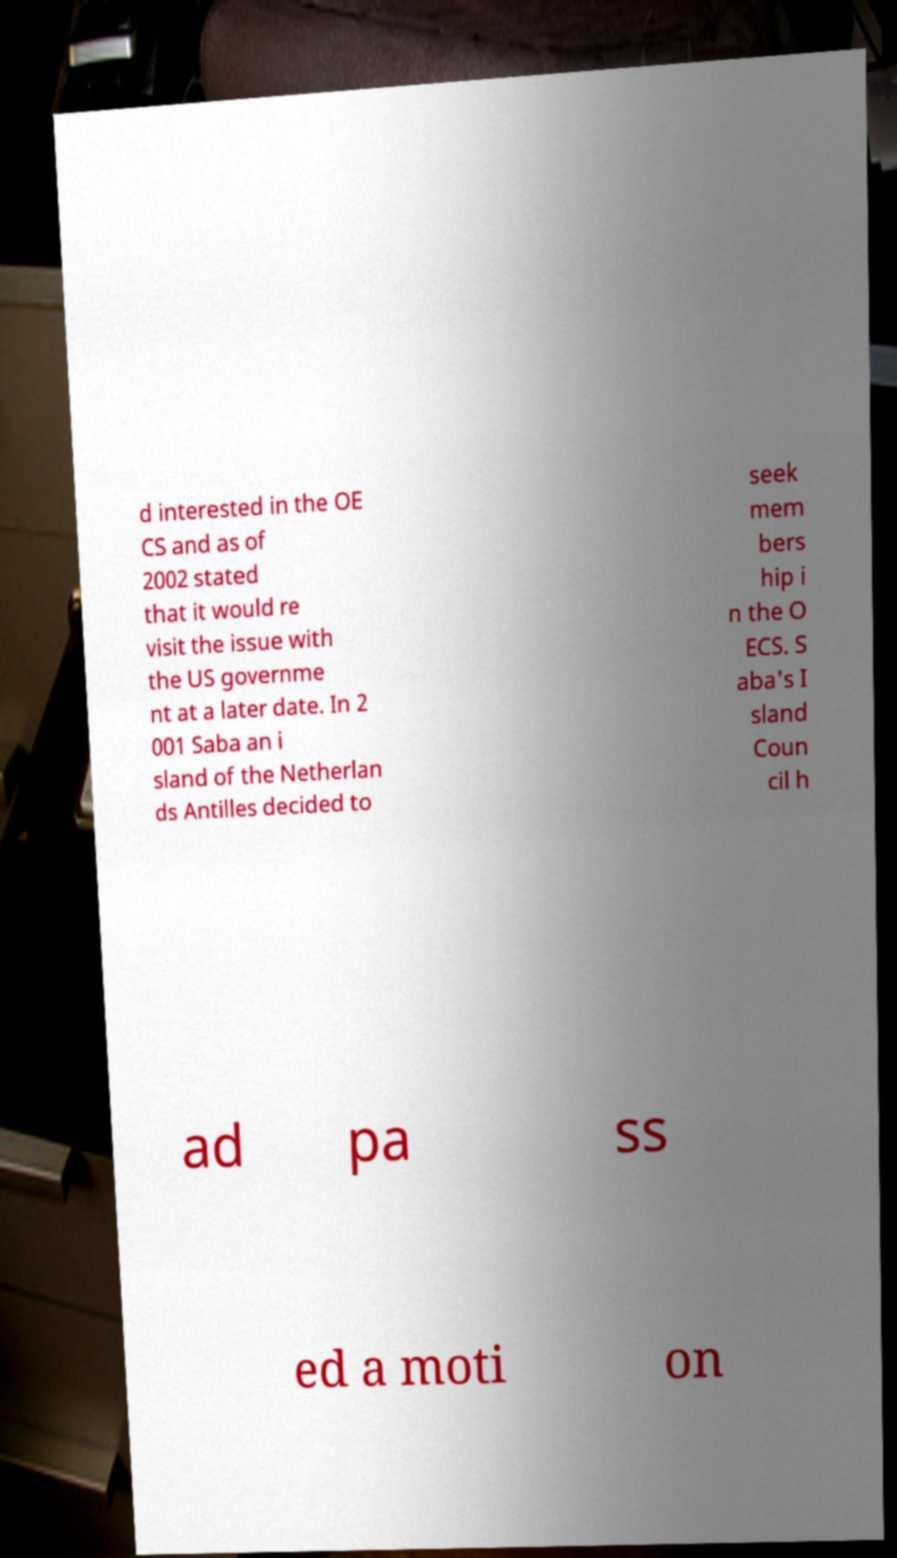What messages or text are displayed in this image? I need them in a readable, typed format. d interested in the OE CS and as of 2002 stated that it would re visit the issue with the US governme nt at a later date. In 2 001 Saba an i sland of the Netherlan ds Antilles decided to seek mem bers hip i n the O ECS. S aba's I sland Coun cil h ad pa ss ed a moti on 